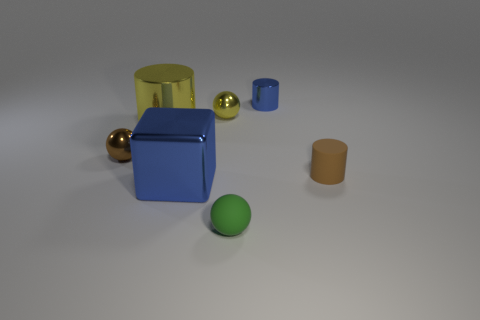Add 3 metallic cylinders. How many objects exist? 10 Subtract all cylinders. How many objects are left? 4 Add 5 metal cylinders. How many metal cylinders exist? 7 Subtract 0 gray cylinders. How many objects are left? 7 Subtract all blue metal blocks. Subtract all big blue metallic blocks. How many objects are left? 5 Add 7 tiny blue metallic cylinders. How many tiny blue metallic cylinders are left? 8 